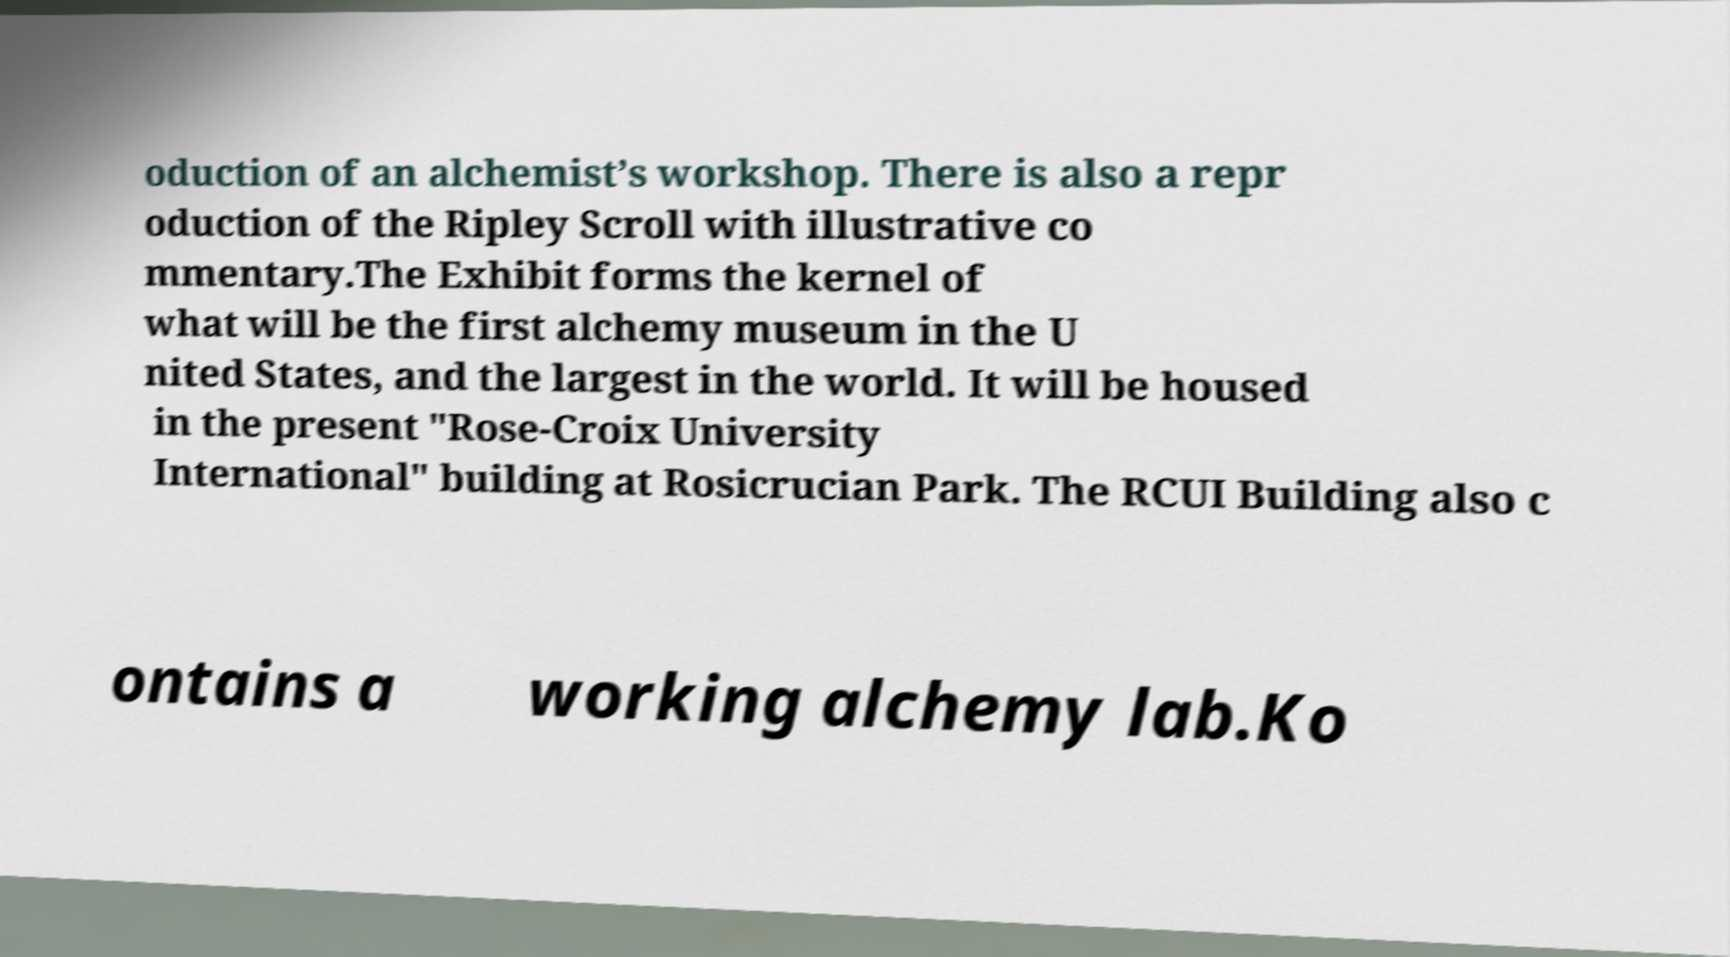There's text embedded in this image that I need extracted. Can you transcribe it verbatim? oduction of an alchemist’s workshop. There is also a repr oduction of the Ripley Scroll with illustrative co mmentary.The Exhibit forms the kernel of what will be the first alchemy museum in the U nited States, and the largest in the world. It will be housed in the present "Rose-Croix University International" building at Rosicrucian Park. The RCUI Building also c ontains a working alchemy lab.Ko 